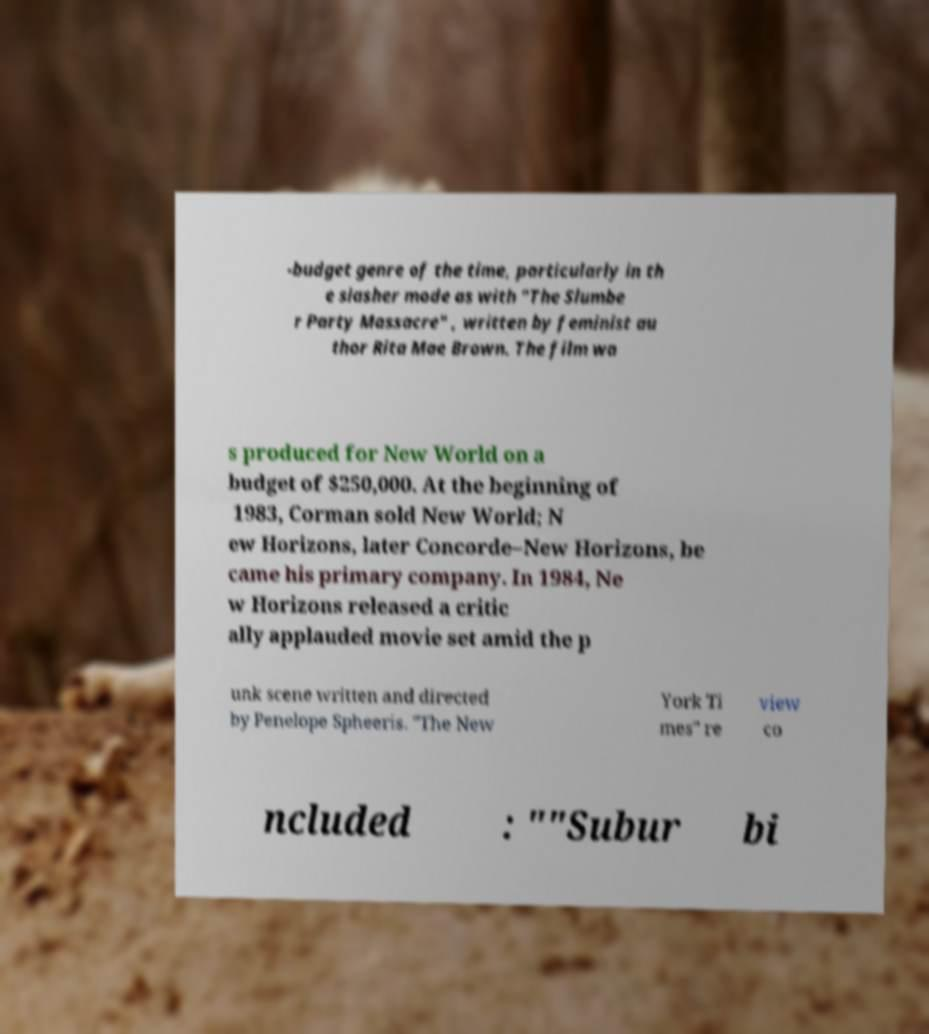Can you accurately transcribe the text from the provided image for me? -budget genre of the time, particularly in th e slasher mode as with "The Slumbe r Party Massacre" , written by feminist au thor Rita Mae Brown. The film wa s produced for New World on a budget of $250,000. At the beginning of 1983, Corman sold New World; N ew Horizons, later Concorde–New Horizons, be came his primary company. In 1984, Ne w Horizons released a critic ally applauded movie set amid the p unk scene written and directed by Penelope Spheeris. "The New York Ti mes" re view co ncluded : ""Subur bi 